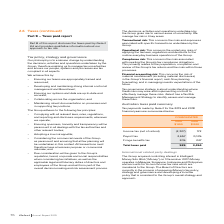From Iselect's financial document, What is the Income tax (net of refund) for 2019 and 2018 respectively? The document shows two values: (2,327) and 172 (in thousands). From the document: "Income tax (net of refund) (2,327) 172 Income tax (net of refund) (2,327) 172..." Also, What is the payroll tax for 2019 and 2018 respectively? The document shows two values: 2,657 and 3,035 (in thousands). From the document: "Payroll tax 2,657 3,035 Payroll tax 2,657 3,035..." Also, What is the total taxes paid for 2019 and 2018 respectively? The document shows two values: 535 and 3,454 (in thousands). From the document: "Total taxes paid 535 3,454 Total taxes paid 535 3,454..." Also, can you calculate: What is the percentage change in the payroll tax from 2018 to 2019? To answer this question, I need to perform calculations using the financial data. The calculation is: (2,657-3,035)/3,035, which equals -12.45 (percentage). This is based on the information: "Payroll tax 2,657 3,035 Payroll tax 2,657 3,035..." The key data points involved are: 2,657, 3,035. Also, can you calculate: What is the percentage change in the fringe benefits tax from 2018 to 2019? To answer this question, I need to perform calculations using the financial data. The calculation is: (205-247)/247, which equals -17 (percentage). This is based on the information: "Fringe benefits tax 205 247 Fringe benefits tax 205 247..." The key data points involved are: 205, 247. Also, can you calculate: What is the percentage change in the total taxes paid from 2018 to 2019? To answer this question, I need to perform calculations using the financial data. The calculation is: (535-3,454)/3,454, which equals -84.51 (percentage). This is based on the information: "Total taxes paid 535 3,454 Total taxes paid 535 3,454..." The key data points involved are: 3,454, 535. 